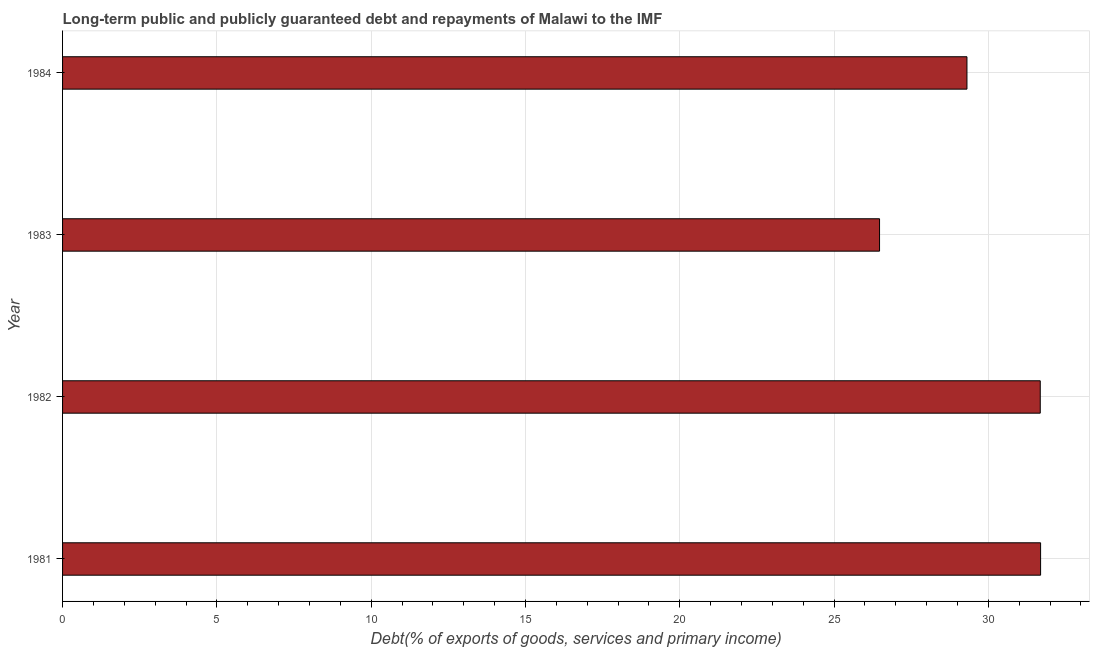Does the graph contain any zero values?
Give a very brief answer. No. Does the graph contain grids?
Keep it short and to the point. Yes. What is the title of the graph?
Ensure brevity in your answer.  Long-term public and publicly guaranteed debt and repayments of Malawi to the IMF. What is the label or title of the X-axis?
Provide a short and direct response. Debt(% of exports of goods, services and primary income). What is the label or title of the Y-axis?
Your answer should be very brief. Year. What is the debt service in 1983?
Your answer should be very brief. 26.48. Across all years, what is the maximum debt service?
Provide a succinct answer. 31.7. Across all years, what is the minimum debt service?
Keep it short and to the point. 26.48. In which year was the debt service maximum?
Provide a short and direct response. 1981. What is the sum of the debt service?
Your response must be concise. 119.16. What is the difference between the debt service in 1983 and 1984?
Give a very brief answer. -2.83. What is the average debt service per year?
Keep it short and to the point. 29.79. What is the median debt service?
Provide a short and direct response. 30.5. In how many years, is the debt service greater than 18 %?
Provide a short and direct response. 4. What is the ratio of the debt service in 1981 to that in 1984?
Give a very brief answer. 1.08. What is the difference between the highest and the second highest debt service?
Your answer should be very brief. 0.01. Is the sum of the debt service in 1982 and 1983 greater than the maximum debt service across all years?
Offer a terse response. Yes. What is the difference between the highest and the lowest debt service?
Make the answer very short. 5.22. In how many years, is the debt service greater than the average debt service taken over all years?
Your answer should be compact. 2. Are all the bars in the graph horizontal?
Give a very brief answer. Yes. What is the Debt(% of exports of goods, services and primary income) in 1981?
Offer a very short reply. 31.7. What is the Debt(% of exports of goods, services and primary income) of 1982?
Keep it short and to the point. 31.68. What is the Debt(% of exports of goods, services and primary income) in 1983?
Your response must be concise. 26.48. What is the Debt(% of exports of goods, services and primary income) of 1984?
Provide a short and direct response. 29.31. What is the difference between the Debt(% of exports of goods, services and primary income) in 1981 and 1982?
Offer a very short reply. 0.01. What is the difference between the Debt(% of exports of goods, services and primary income) in 1981 and 1983?
Offer a very short reply. 5.22. What is the difference between the Debt(% of exports of goods, services and primary income) in 1981 and 1984?
Your answer should be very brief. 2.39. What is the difference between the Debt(% of exports of goods, services and primary income) in 1982 and 1983?
Your answer should be compact. 5.21. What is the difference between the Debt(% of exports of goods, services and primary income) in 1982 and 1984?
Your answer should be compact. 2.38. What is the difference between the Debt(% of exports of goods, services and primary income) in 1983 and 1984?
Offer a very short reply. -2.83. What is the ratio of the Debt(% of exports of goods, services and primary income) in 1981 to that in 1983?
Your answer should be very brief. 1.2. What is the ratio of the Debt(% of exports of goods, services and primary income) in 1981 to that in 1984?
Your response must be concise. 1.08. What is the ratio of the Debt(% of exports of goods, services and primary income) in 1982 to that in 1983?
Make the answer very short. 1.2. What is the ratio of the Debt(% of exports of goods, services and primary income) in 1982 to that in 1984?
Keep it short and to the point. 1.08. What is the ratio of the Debt(% of exports of goods, services and primary income) in 1983 to that in 1984?
Provide a short and direct response. 0.9. 